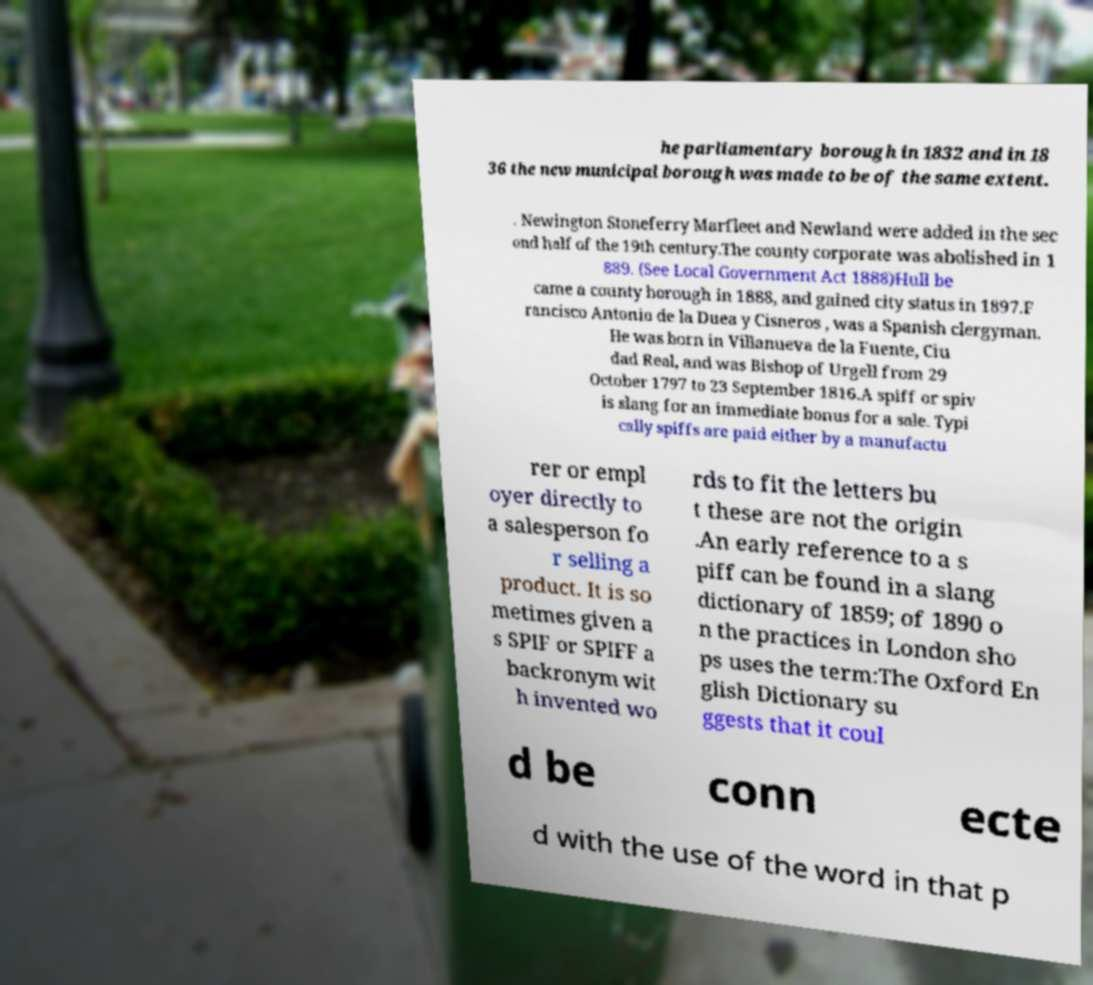Please read and relay the text visible in this image. What does it say? he parliamentary borough in 1832 and in 18 36 the new municipal borough was made to be of the same extent. . Newington Stoneferry Marfleet and Newland were added in the sec ond half of the 19th century.The county corporate was abolished in 1 889. (See Local Government Act 1888)Hull be came a county borough in 1888, and gained city status in 1897.F rancisco Antonio de la Duea y Cisneros , was a Spanish clergyman. He was born in Villanueva de la Fuente, Ciu dad Real, and was Bishop of Urgell from 29 October 1797 to 23 September 1816.A spiff or spiv is slang for an immediate bonus for a sale. Typi cally spiffs are paid either by a manufactu rer or empl oyer directly to a salesperson fo r selling a product. It is so metimes given a s SPIF or SPIFF a backronym wit h invented wo rds to fit the letters bu t these are not the origin .An early reference to a s piff can be found in a slang dictionary of 1859; of 1890 o n the practices in London sho ps uses the term:The Oxford En glish Dictionary su ggests that it coul d be conn ecte d with the use of the word in that p 